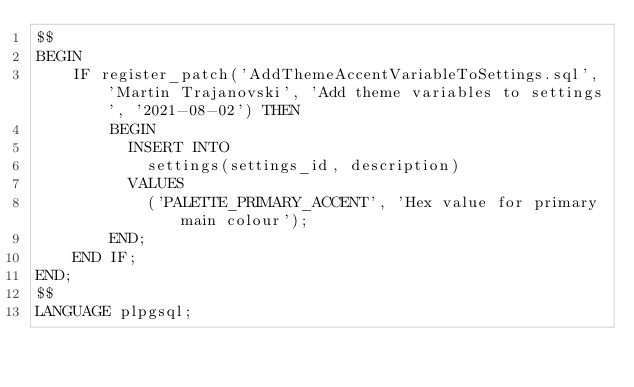<code> <loc_0><loc_0><loc_500><loc_500><_SQL_>$$
BEGIN
	IF register_patch('AddThemeAccentVariableToSettings.sql', 'Martin Trajanovski', 'Add theme variables to settings', '2021-08-02') THEN
		BEGIN
		  INSERT INTO 
			settings(settings_id, description)
		  VALUES
			('PALETTE_PRIMARY_ACCENT', 'Hex value for primary main colour');
		END;
	END IF;
END;
$$
LANGUAGE plpgsql;
</code> 